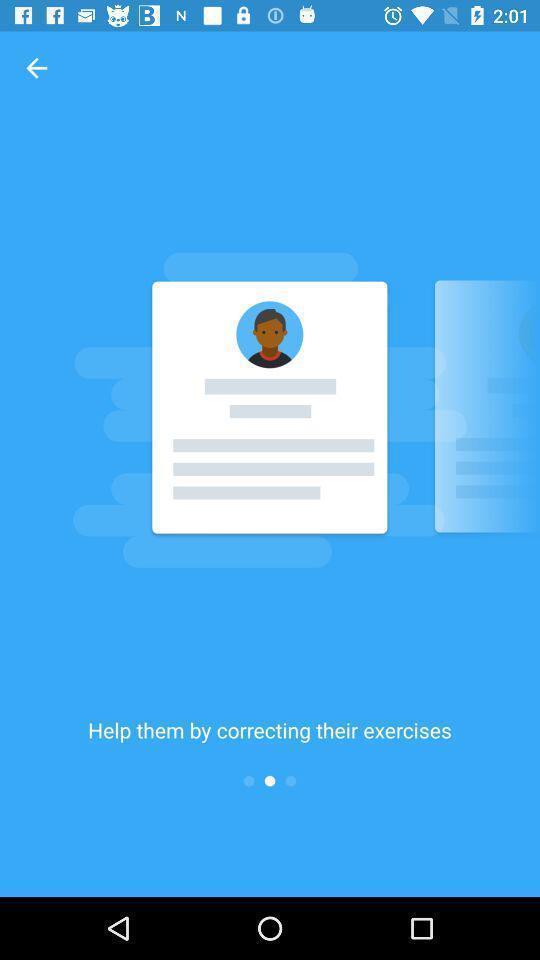Provide a textual representation of this image. Welcome page of a language learning application. 